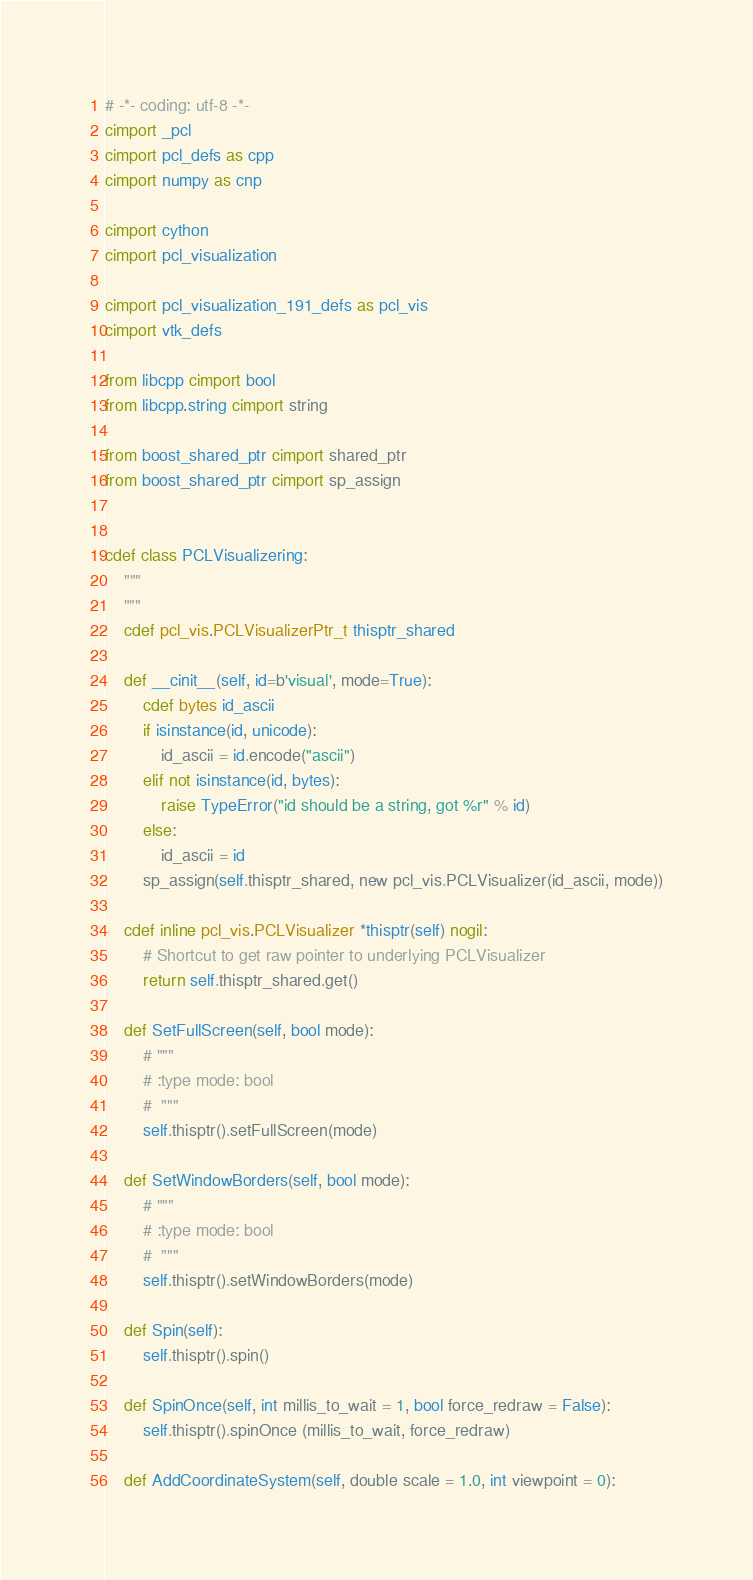Convert code to text. <code><loc_0><loc_0><loc_500><loc_500><_Cython_># -*- coding: utf-8 -*-
cimport _pcl
cimport pcl_defs as cpp
cimport numpy as cnp

cimport cython
cimport pcl_visualization

cimport pcl_visualization_191_defs as pcl_vis
cimport vtk_defs

from libcpp cimport bool
from libcpp.string cimport string

from boost_shared_ptr cimport shared_ptr
from boost_shared_ptr cimport sp_assign


cdef class PCLVisualizering:
    """
    """
    cdef pcl_vis.PCLVisualizerPtr_t thisptr_shared

    def __cinit__(self, id=b'visual', mode=True):
        cdef bytes id_ascii
        if isinstance(id, unicode):
            id_ascii = id.encode("ascii")
        elif not isinstance(id, bytes):
            raise TypeError("id should be a string, got %r" % id)
        else:
            id_ascii = id
        sp_assign(self.thisptr_shared, new pcl_vis.PCLVisualizer(id_ascii, mode))

    cdef inline pcl_vis.PCLVisualizer *thisptr(self) nogil:
        # Shortcut to get raw pointer to underlying PCLVisualizer
        return self.thisptr_shared.get()

    def SetFullScreen(self, bool mode):
        # """
        # :type mode: bool
        #  """
        self.thisptr().setFullScreen(mode)

    def SetWindowBorders(self, bool mode):
        # """
        # :type mode: bool
        #  """
        self.thisptr().setWindowBorders(mode)

    def Spin(self):
        self.thisptr().spin()

    def SpinOnce(self, int millis_to_wait = 1, bool force_redraw = False):
        self.thisptr().spinOnce (millis_to_wait, force_redraw)

    def AddCoordinateSystem(self, double scale = 1.0, int viewpoint = 0):</code> 